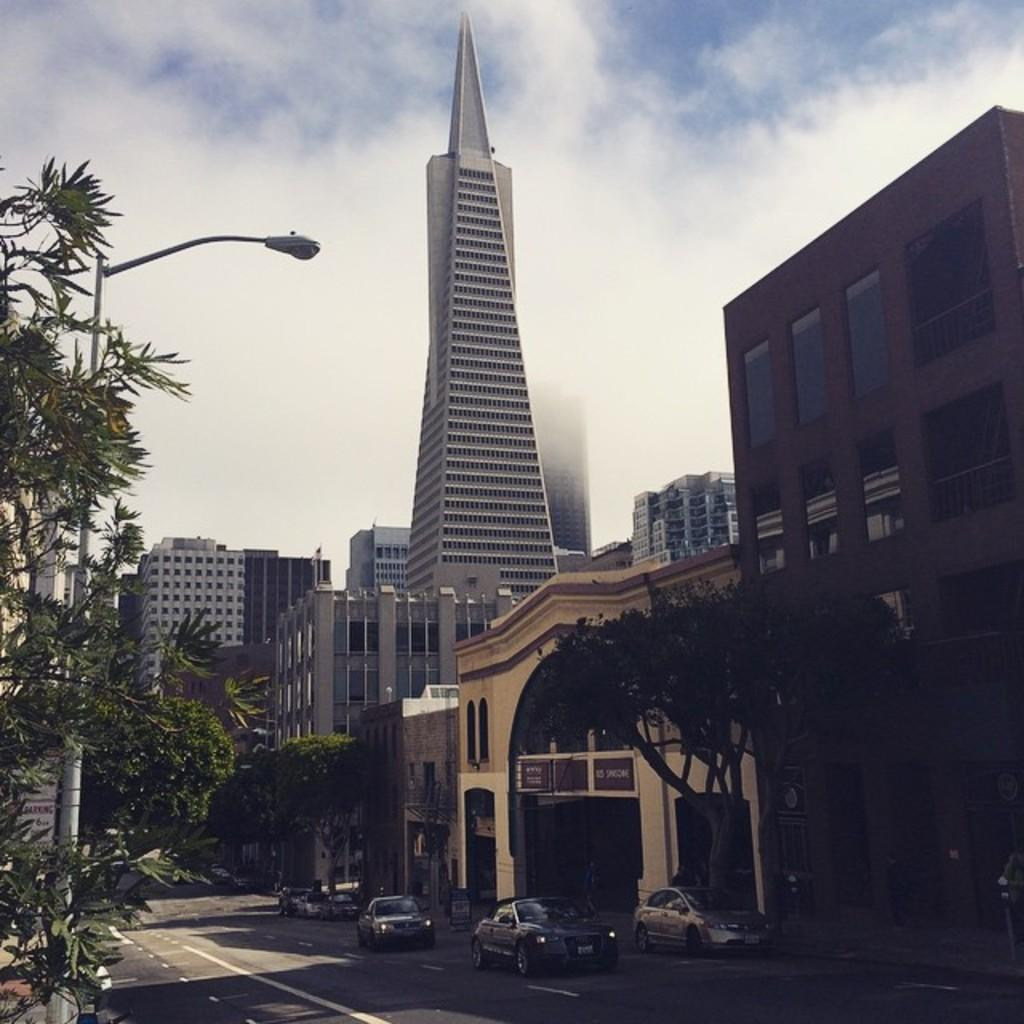What type of structures can be seen in the image? There are buildings in the image. What type of lighting is present in the image? There is a street lamp in the image. What type of vegetation is visible in the image? There are trees in the image. What type of vehicles are present in the image? There are cars in the image. What is visible at the top of the image? The sky is visible at the top of the image. Can you tell me how many pets are visible in the image? There are no pets present in the image. What type of garden can be seen in the image? There is no garden present in the image. 